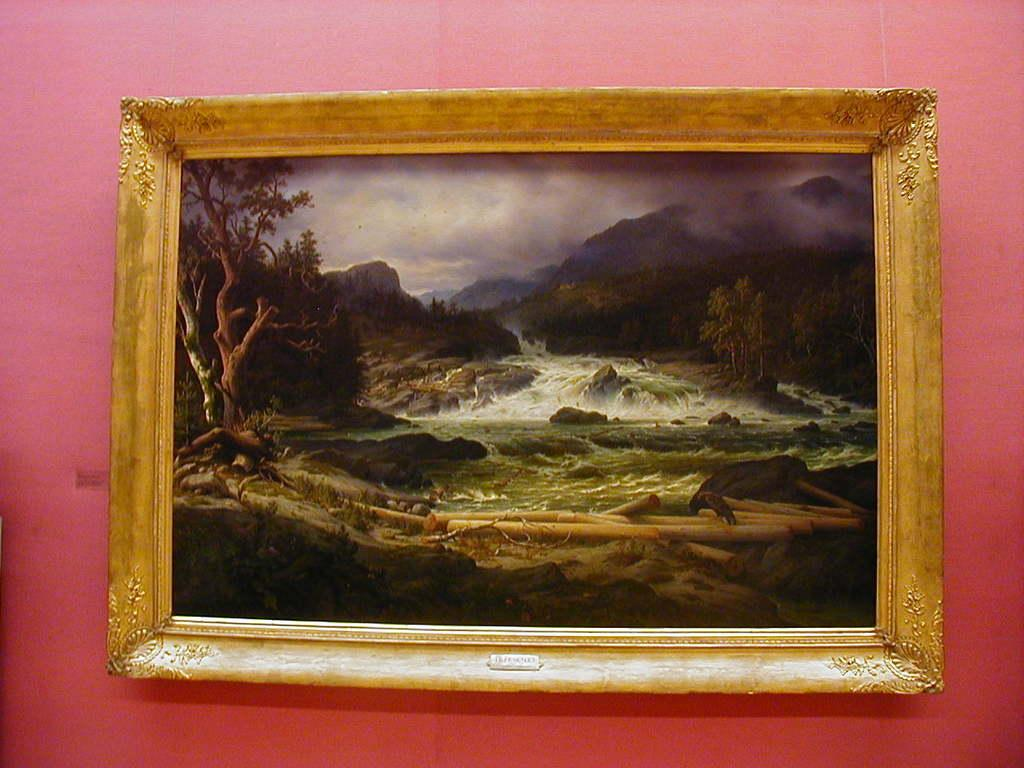What can be seen in the image? There is a wall in the image. What is on the wall? There is a photo frame on the wall. What type of dress is the wall wearing in the image? The wall is not wearing a dress, as it is an inanimate object and does not have the ability to wear clothing. 